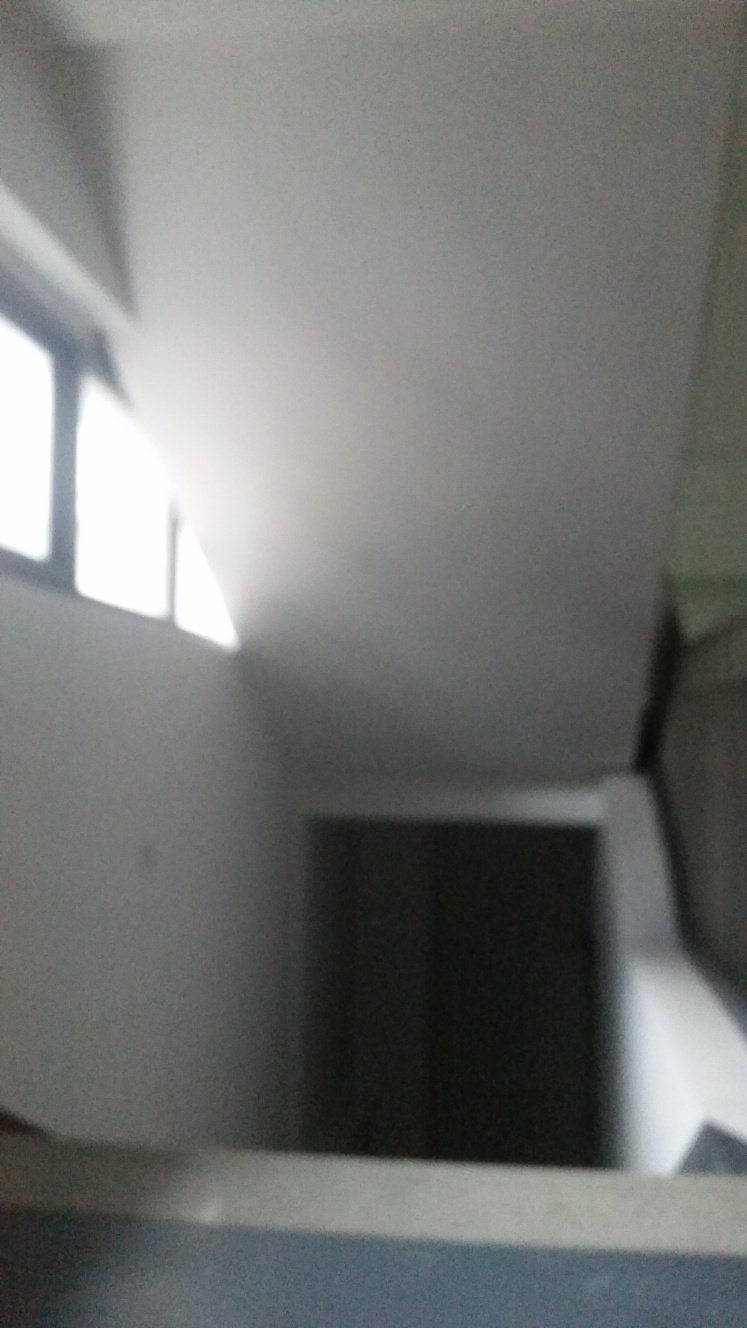How would you describe the quality of this image? The image is of significantly low quality. It is blurry, lacks sharpness and the subjects are not clearly identifiable. Moreover, the lighting conditions are poor, contributing to the difficulty in discerning details. The composition could be vastly improved by achieving better focus, stabilizing the camera, ensuring sufficient lighting, and framing the subjects more deliberately. 